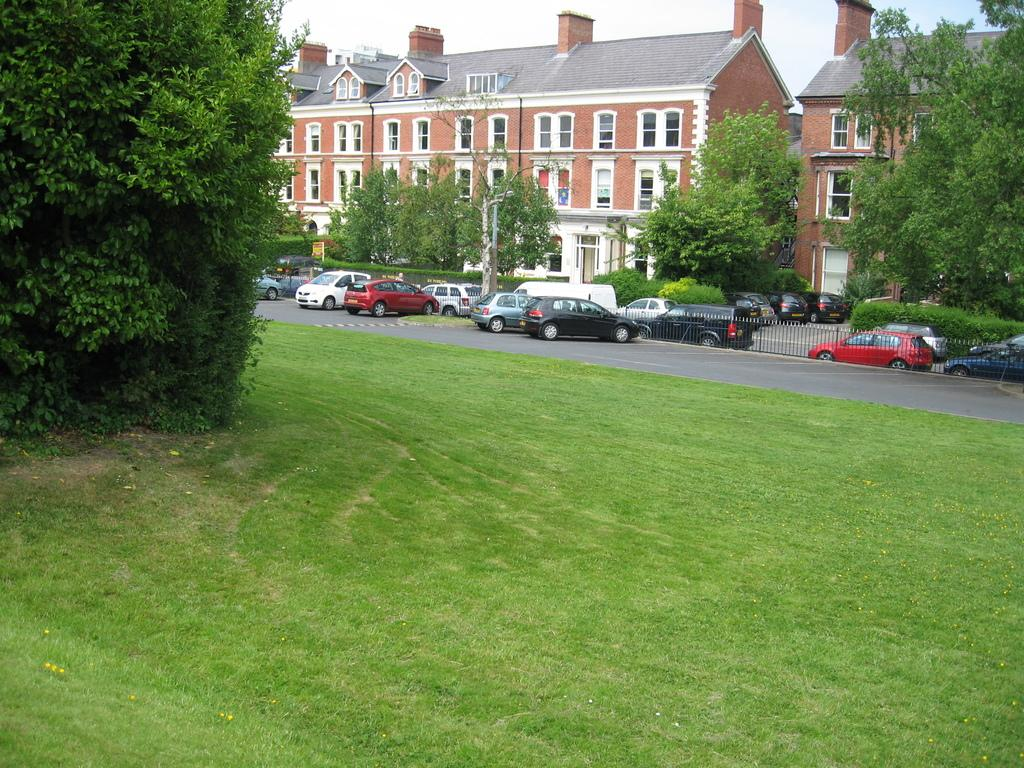What can be seen on the road in the image? There are vehicles on the road in the image. What is visible in the background of the image? There are trees, poles, a fence, and buildings in the background of the image. What part of the natural environment is visible in the image? The sky is visible at the top of the image. What part of the man-made environment is visible in the image? The ground is visible at the bottom of the image. How many balls are bouncing on the fence in the image? There are no balls present in the image, and therefore no such activity can be observed. What type of house is visible in the image? There is no house visible in the image; it features vehicles on the road, trees, poles, a fence, buildings, the sky, and the ground. 